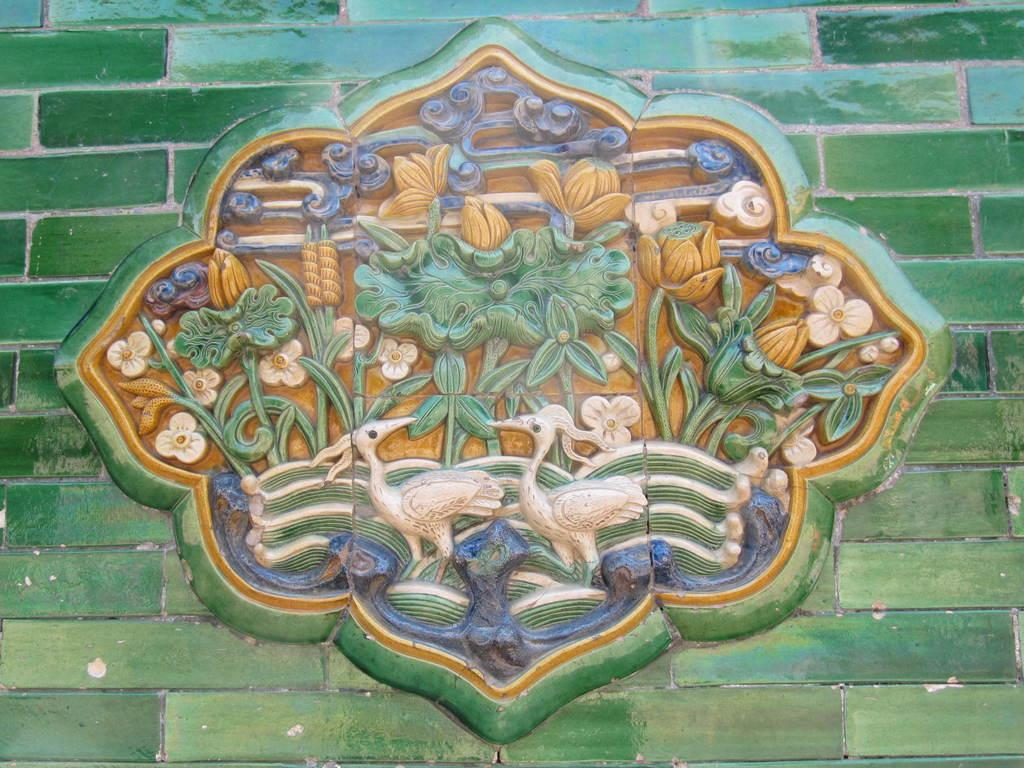What can be seen on the wall in the image? There are carvings on the wall in the image. What shape is the health of the person's face in the image? There is no person or face present in the image, so it is not possible to determine the shape of their health. 